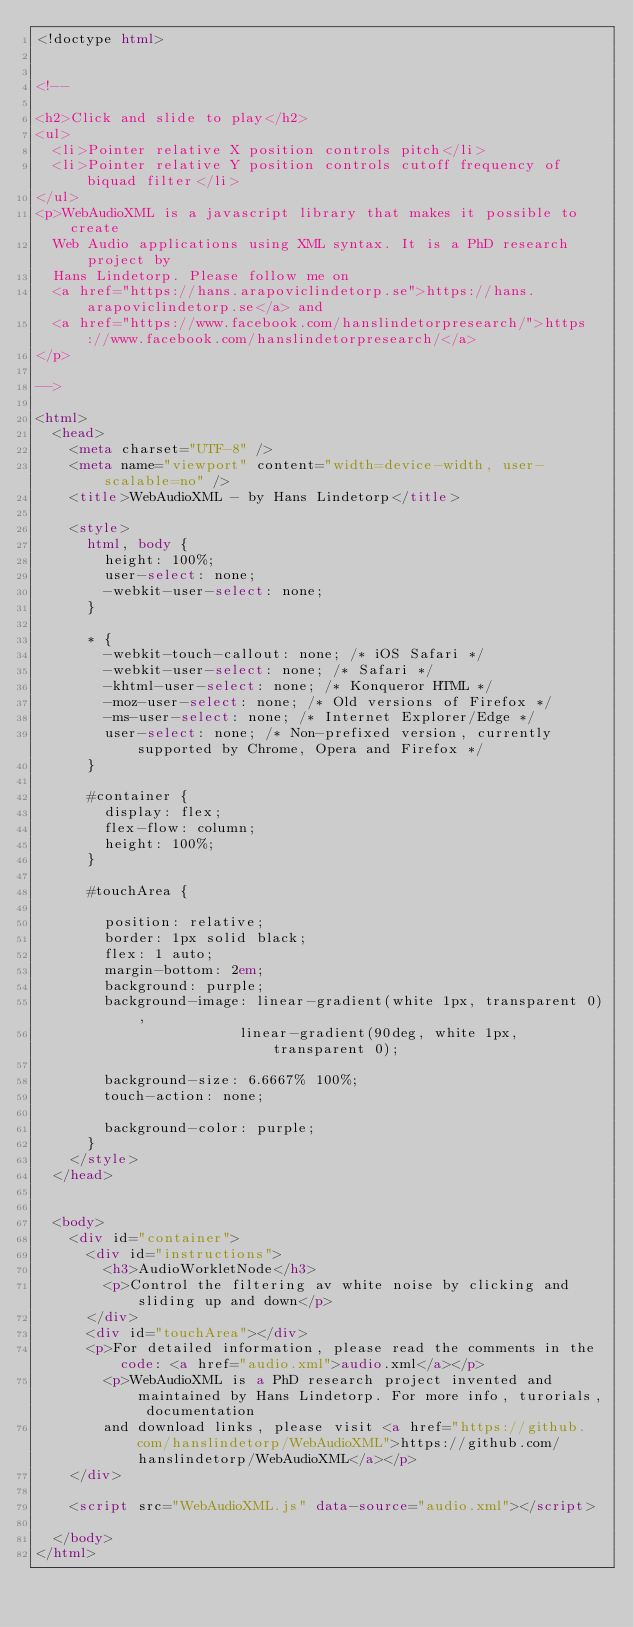<code> <loc_0><loc_0><loc_500><loc_500><_HTML_><!doctype html>


<!--

<h2>Click and slide to play</h2>
<ul>
	<li>Pointer relative X position controls pitch</li>
	<li>Pointer relative Y position controls cutoff frequency of biquad filter</li>
</ul>
<p>WebAudioXML is a javascript library that makes it possible to create
	Web Audio applications using XML syntax. It is a PhD research project by
	Hans Lindetorp. Please follow me on
	<a href="https://hans.arapoviclindetorp.se">https://hans.arapoviclindetorp.se</a> and
	<a href="https://www.facebook.com/hanslindetorpresearch/">https://www.facebook.com/hanslindetorpresearch/</a>
</p>

-->

<html>
	<head>
		<meta charset="UTF-8" />
		<meta name="viewport" content="width=device-width, user-scalable=no" />
		<title>WebAudioXML - by Hans Lindetorp</title>

		<style>
			html, body {
				height: 100%;
				user-select: none;
				-webkit-user-select: none;
			}

			* {
			  -webkit-touch-callout: none; /* iOS Safari */
			  -webkit-user-select: none; /* Safari */
			  -khtml-user-select: none; /* Konqueror HTML */
			  -moz-user-select: none; /* Old versions of Firefox */
			  -ms-user-select: none; /* Internet Explorer/Edge */
			  user-select: none; /* Non-prefixed version, currently supported by Chrome, Opera and Firefox */
			}

			#container {
			  display: flex;
			  flex-flow: column;
			  height: 100%;
			}

			#touchArea {

				position: relative;
			  border: 1px solid black;
			  flex: 1 auto;
			  margin-bottom: 2em;
			  background: purple;
				background-image: linear-gradient(white 1px, transparent 0),
			                  linear-gradient(90deg, white 1px, transparent 0);

			  background-size: 6.6667% 100%;
			  touch-action: none;

				background-color: purple;
			}
		</style>
	</head>


	<body>
		<div id="container">
			<div id="instructions">
				<h3>AudioWorkletNode</h3>
				<p>Control the filtering av white noise by clicking and sliding up and down</p>
			</div>
			<div id="touchArea"></div>
			<p>For detailed information, please read the comments in the code: <a href="audio.xml">audio.xml</a></p>
				<p>WebAudioXML is a PhD research project invented and maintained by Hans Lindetorp. For more info, turorials, documentation 
				and download links, please visit <a href="https://github.com/hanslindetorp/WebAudioXML">https://github.com/hanslindetorp/WebAudioXML</a></p>
		</div>

		<script src="WebAudioXML.js" data-source="audio.xml"></script>

	</body>
</html>
</code> 